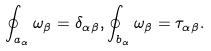Convert formula to latex. <formula><loc_0><loc_0><loc_500><loc_500>\oint _ { a _ { \alpha } } \omega _ { \beta } = \delta _ { \alpha \beta } , \oint _ { b _ { \alpha } } \omega _ { \beta } = \tau _ { \alpha \beta } .</formula> 